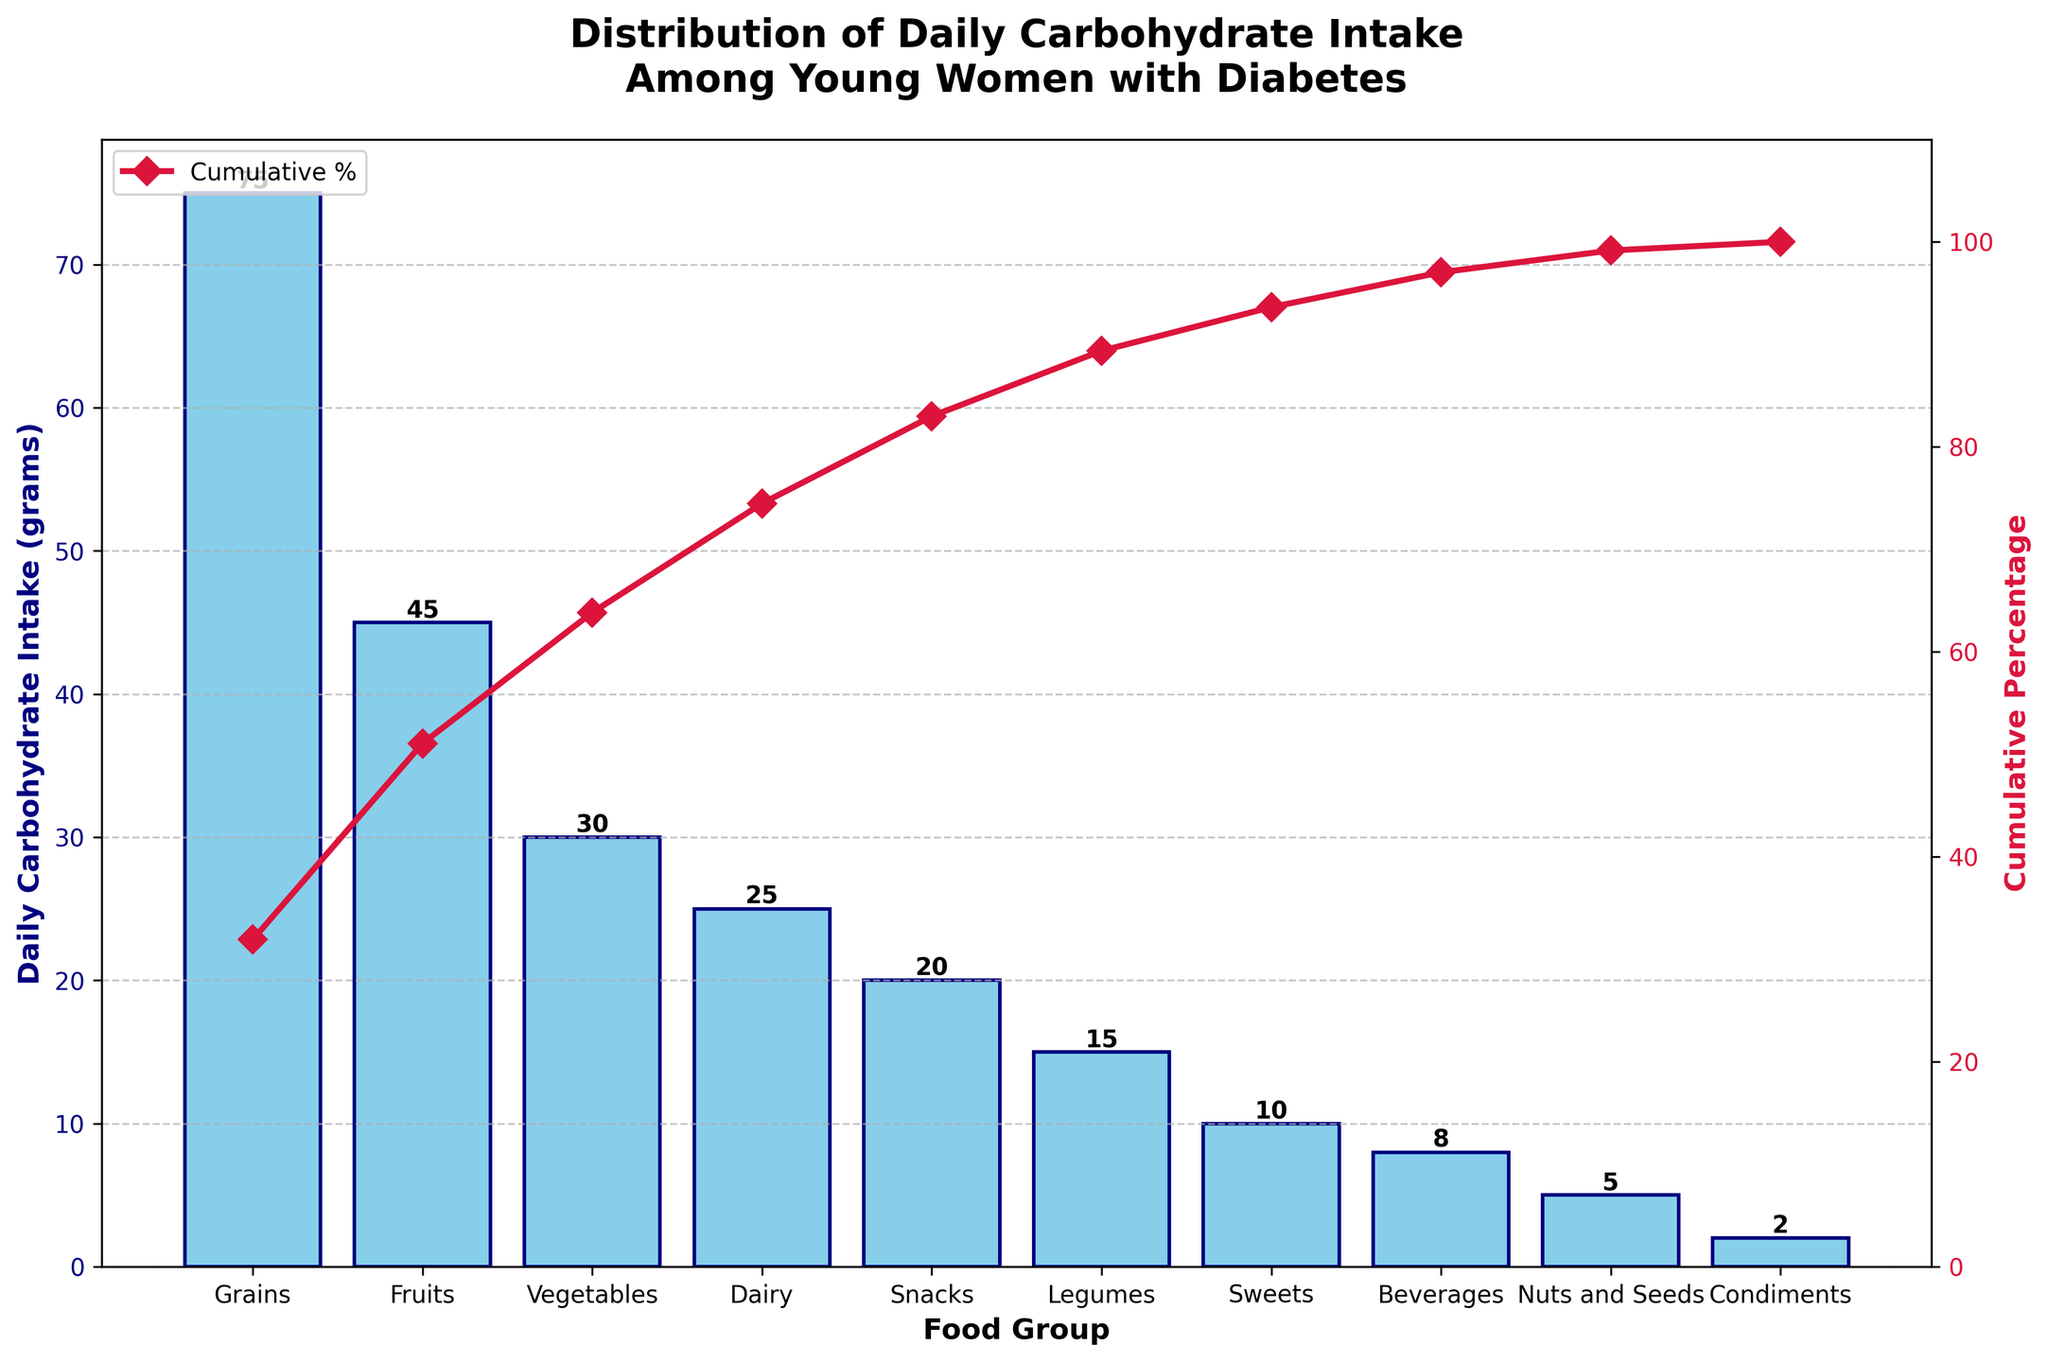What's the title of the figure? The title of the figure is displayed at the top and reads 'Distribution of Daily Carbohydrate Intake Among Young Women with Diabetes'.
Answer: Distribution of Daily Carbohydrate Intake Among Young Women with Diabetes How many food groups are included in the Pareto chart? The x-axis labels show the food groups, and each bar represents a food group. Counting these labels or bars, we find there are 10 food groups included.
Answer: 10 Which food group has the highest daily carbohydrate intake, and what is the amount? By observing the heights of the bars, the tallest bar represents the food group 'Grains,' with a corresponding value label indicating it has 75 grams.
Answer: Grains, 75 grams What is the cumulative percentage of daily carbohydrate intake after including the top two food groups? The cumulative percentage line in the chart helps us find these values. At 'Grains,' it starts at approximately 26% and after 'Fruits,' it reaches around 50%.
Answer: 50% What are the food groups that contribute to at least 80% of the daily carbohydrate intake? Following the cumulative percentage line, we see that up to 80% includes 'Grains,' 'Fruits,' 'Vegetables,' and 'Dairy.'
Answer: Grains, Fruits, Vegetables, Dairy How does the daily carbohydrate intake from 'Snacks' compare to that from 'Legumes'? Checking the heights of the bars and their value labels, 'Snacks' contribute 20 grams while 'Legumes' contribute 15 grams. Comparison indicates that 'Snacks' have a higher daily carbohydrate intake by 5 grams.
Answer: Snacks have 5 grams more Which food groups have a daily carbohydrate intake of less than 10 grams? Observing the bars, 'Beverages,' 'Nuts and Seeds,' and 'Condiments' have value labels showing 8 grams, 5 grams, and 2 grams respectively.
Answer: Beverages, Nuts and Seeds, Condiments What proportion of daily carbohydrate intake is from 'Vegetables' relative to 'Grains'? 'Vegetables' have 30 grams, and 'Grains' have 75 grams. Proportion calculation: 30/75 = 0.4 or 40%.
Answer: 40% By how much does the daily carbohydrate intake of 'Dairy' exceed that of 'Sweets'? 'Dairy' has 25 grams, and 'Sweets' have 10 grams. The difference is 25 - 10 = 15 grams.
Answer: 15 grams What is the cumulative percentage after including 'Dairy' but before adding 'Snacks'? Looking at the cumulative percentage line just before 'Snacks,' it is around 68%, including 'Dairy' but excluding 'Snacks'.
Answer: 68% 